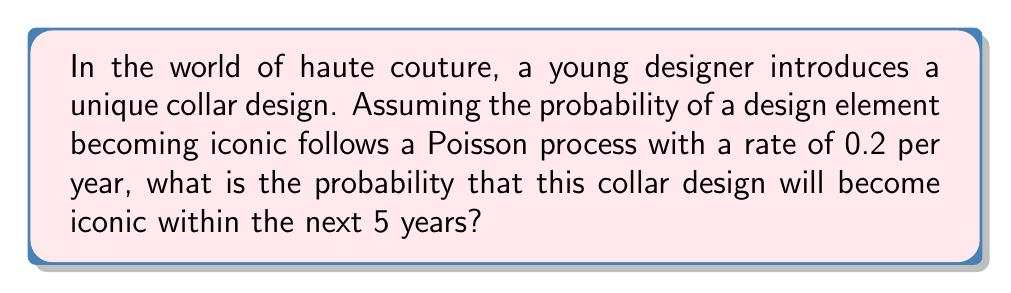Help me with this question. To solve this problem, we'll use the properties of a Poisson process:

1) Let $X(t)$ be the number of times the design becomes iconic by time $t$.

2) The probability of no events occurring in time interval $[0, t]$ is given by:
   $$P(X(t) = 0) = e^{-\lambda t}$$
   where $\lambda$ is the rate parameter.

3) The probability of at least one event occurring is the complement of no events occurring:
   $$P(X(t) \geq 1) = 1 - P(X(t) = 0) = 1 - e^{-\lambda t}$$

4) Given:
   $\lambda = 0.2$ per year
   $t = 5$ years

5) Substituting these values:
   $$P(X(5) \geq 1) = 1 - e^{-(0.2)(5)}$$

6) Simplifying:
   $$P(X(5) \geq 1) = 1 - e^{-1} \approx 0.6321$$

7) Converting to a percentage:
   $0.6321 \times 100\% \approx 63.21\%$

This result suggests that there's approximately a 63.21% chance that the collar design will become iconic within the next 5 years, reflecting the stochastic nature of fashion trends and the potential for creative elements to gain widespread recognition over time.
Answer: 63.21% 